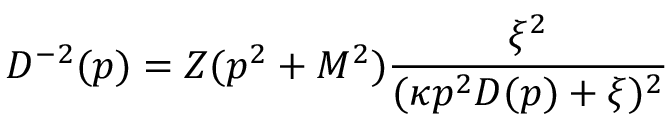<formula> <loc_0><loc_0><loc_500><loc_500>D ^ { - 2 } ( p ) = Z ( p ^ { 2 } + M ^ { 2 } ) \frac { \xi ^ { 2 } } { ( \kappa p ^ { 2 } D ( p ) + \xi ) ^ { 2 } }</formula> 